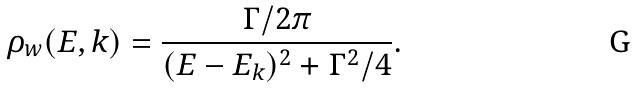<formula> <loc_0><loc_0><loc_500><loc_500>\rho _ { w } ( E , k ) = \frac { \Gamma / 2 \pi } { ( E - E _ { k } ) ^ { 2 } + \Gamma ^ { 2 } / 4 } .</formula> 